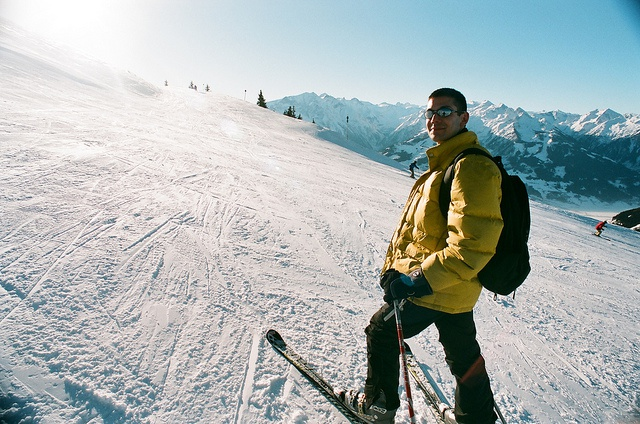Describe the objects in this image and their specific colors. I can see people in lightgray, black, and olive tones, backpack in lightgray, black, darkgreen, and teal tones, skis in lightgray, black, gray, and darkgray tones, people in lightgray, black, gray, and purple tones, and people in lightgray, black, maroon, teal, and red tones in this image. 